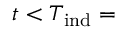Convert formula to latex. <formula><loc_0><loc_0><loc_500><loc_500>t < T _ { i n d } =</formula> 